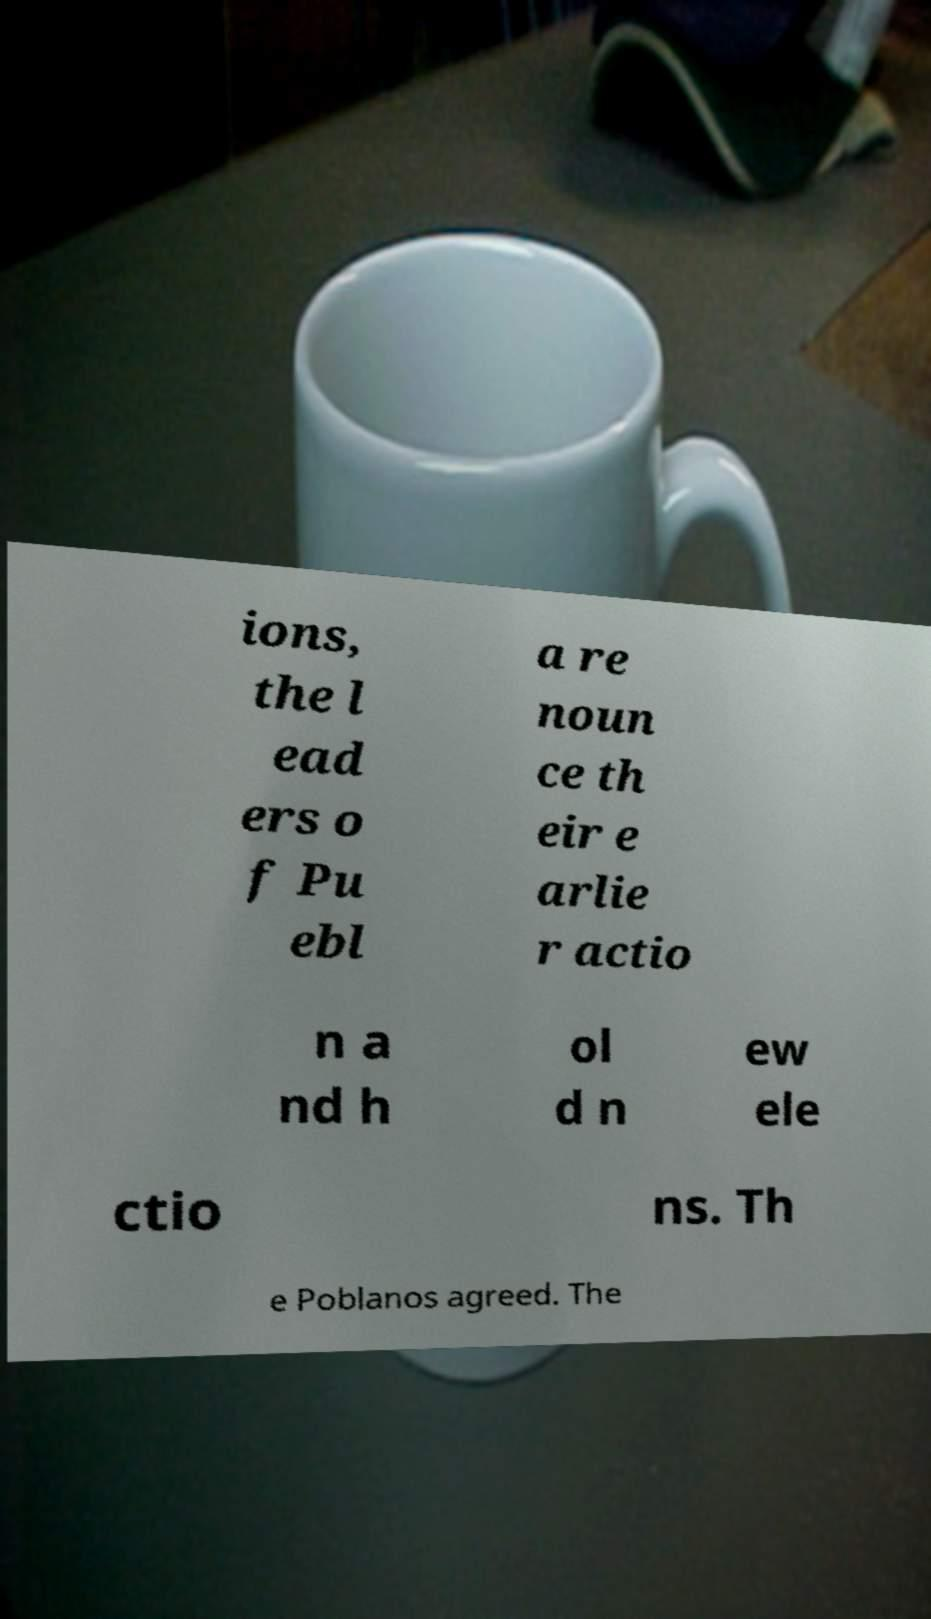There's text embedded in this image that I need extracted. Can you transcribe it verbatim? ions, the l ead ers o f Pu ebl a re noun ce th eir e arlie r actio n a nd h ol d n ew ele ctio ns. Th e Poblanos agreed. The 